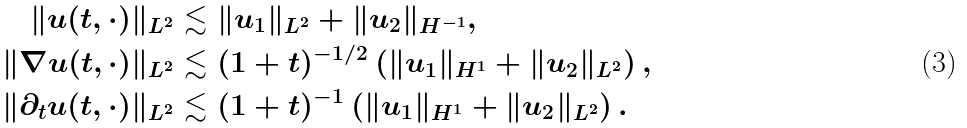Convert formula to latex. <formula><loc_0><loc_0><loc_500><loc_500>\| u ( t , \cdot ) \| _ { L ^ { 2 } } & \lesssim \| u _ { 1 } \| _ { L ^ { 2 } } + \| u _ { 2 } \| _ { H ^ { - 1 } } , \\ \| \nabla u ( t , \cdot ) \| _ { L ^ { 2 } } & \lesssim ( 1 + t ) ^ { - 1 / 2 } \left ( \| u _ { 1 } \| _ { H ^ { 1 } } + \| u _ { 2 } \| _ { L ^ { 2 } } \right ) , \\ \| \partial _ { t } u ( t , \cdot ) \| _ { L ^ { 2 } } & \lesssim ( 1 + t ) ^ { - 1 } \left ( \| u _ { 1 } \| _ { H ^ { 1 } } + \| u _ { 2 } \| _ { L ^ { 2 } } \right ) .</formula> 